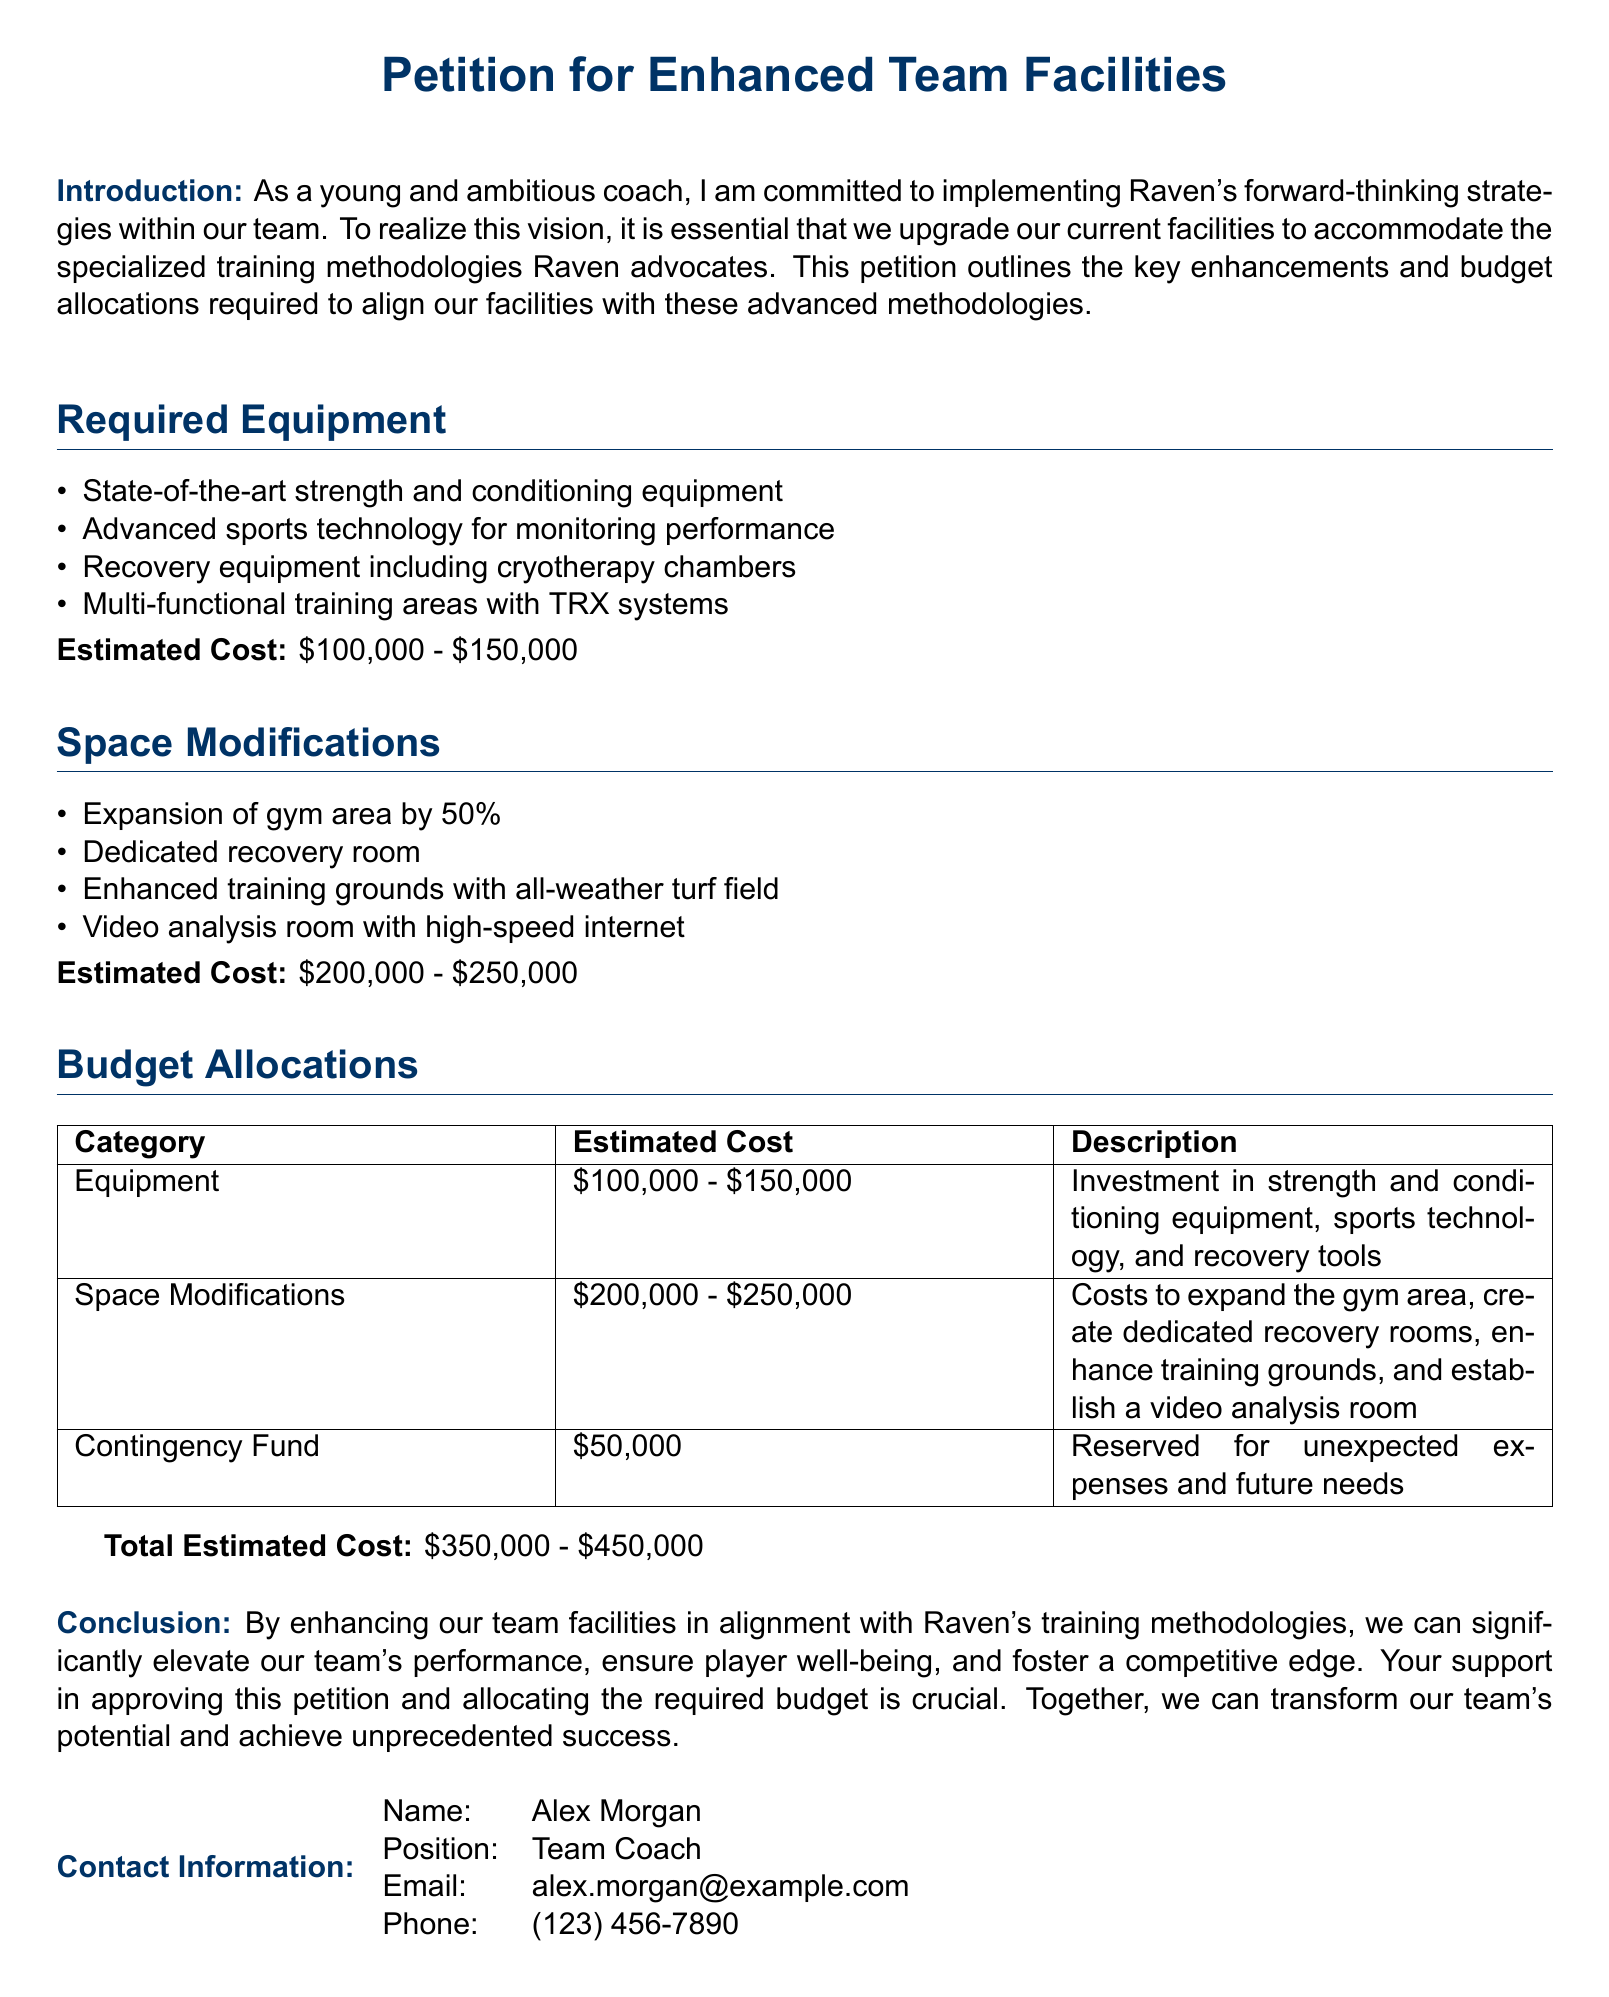What is the title of the document? The title of the document is found at the top and states its purpose clearly.
Answer: Petition for Enhanced Team Facilities Who is the author of the petition? The author's name is listed in the contact information section of the document.
Answer: Alex Morgan What is the estimated cost for the equipment? The estimated cost for the equipment is mentioned under the Required Equipment section.
Answer: $100,000 - $150,000 How much is allocated for the contingency fund? The contingency fund is detailed in the Budget Allocations table.
Answer: $50,000 What is one type of advanced training equipment mentioned? One type of equipment is listed under Required Equipment which indicates the team's focus on advanced methodologies.
Answer: Cryotherapy chambers What percentage will the gym area be expanded by? The stated percentage for the gym area expansion is indicated in the Space Modifications section.
Answer: 50% What is the total estimated cost range for enhancing the facilities? The total estimated cost is provided at the end of the budget allocations.
Answer: $350,000 - $450,000 What is the primary goal of the petition? The goal is outlined in the introduction and summarizes the purpose of the enhancements.
Answer: Align with Raven's training methodologies Which feature is included in the enhanced training grounds? The features are listed under Space Modifications, indicating new infrastructure for better training.
Answer: All-weather turf field 